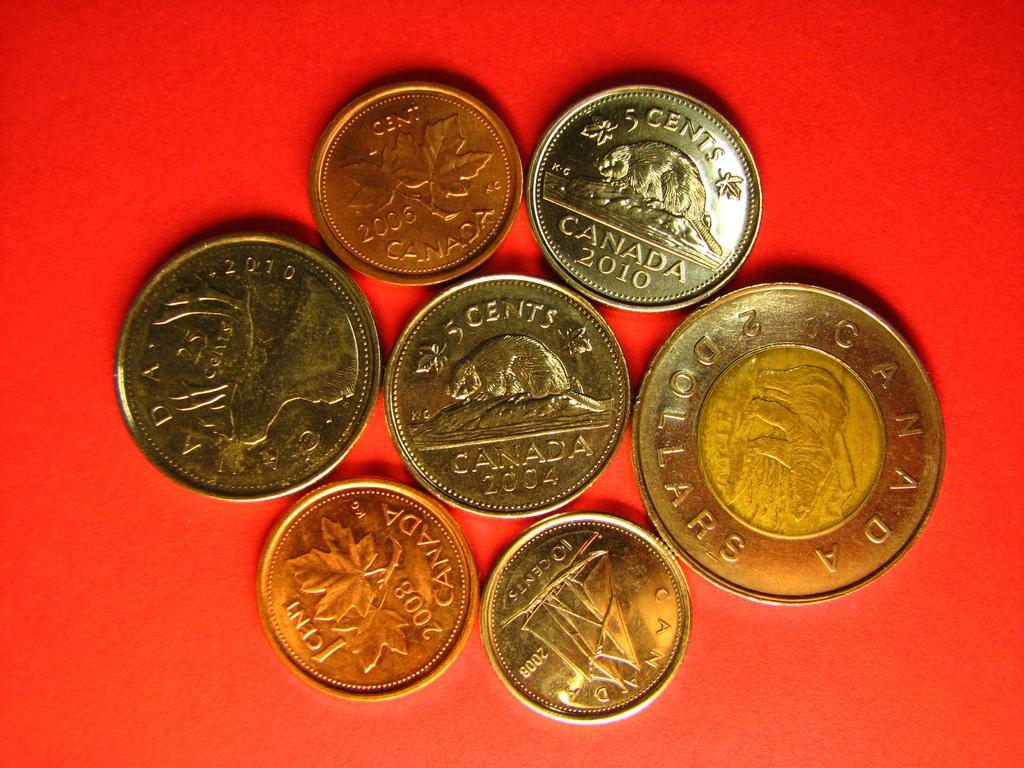Provide a one-sentence caption for the provided image. several canadian coins are laying on a red background. 